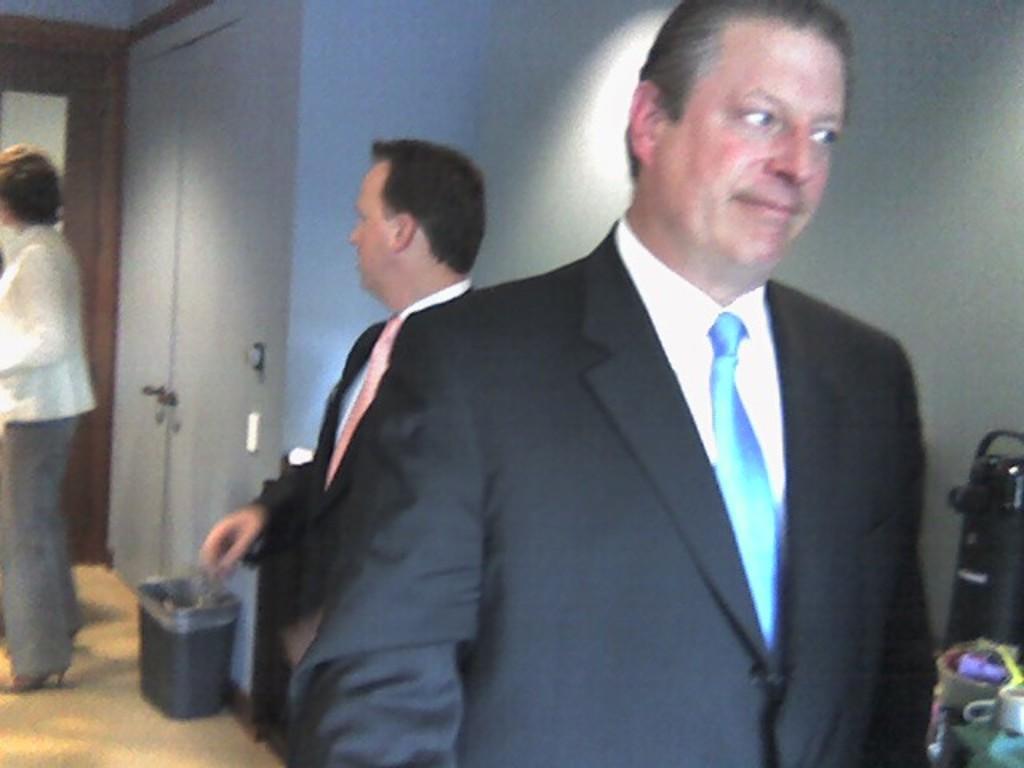In one or two sentences, can you explain what this image depicts? Here in this picture we can see people standing on the floor over there, some of them are wearing coats on them and on the left side we can see a dustbin present on the floor over there and we can see door present and on the right side we can see something present over there. 